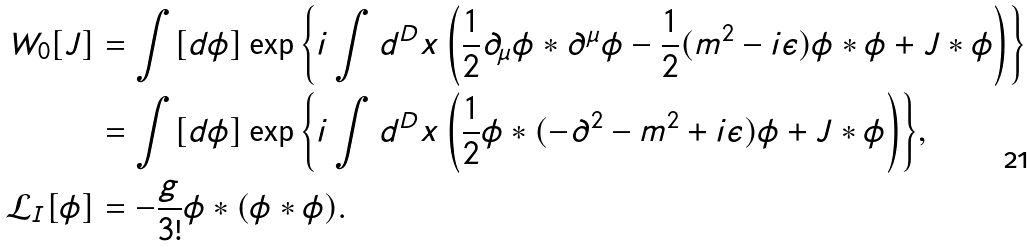Convert formula to latex. <formula><loc_0><loc_0><loc_500><loc_500>W _ { 0 } [ J ] & = \int [ d \phi ] \exp { \left \{ i \int d ^ { D } x \left ( \frac { 1 } { 2 } \partial _ { \mu } \phi \ast \partial ^ { \mu } \phi - \frac { 1 } { 2 } ( m ^ { 2 } - i \epsilon ) \phi \ast \phi + J \ast \phi \right ) \right \} } \\ & = \int [ d \phi ] \exp { \left \{ i \int d ^ { D } x \left ( \frac { 1 } { 2 } \phi \ast ( - \partial ^ { 2 } - m ^ { 2 } + i \epsilon ) \phi + J \ast \phi \right ) \right \} } , \\ \mathcal { L } _ { I } [ \phi ] & = - \frac { g } { 3 ! } \phi \ast ( \phi \ast \phi ) .</formula> 